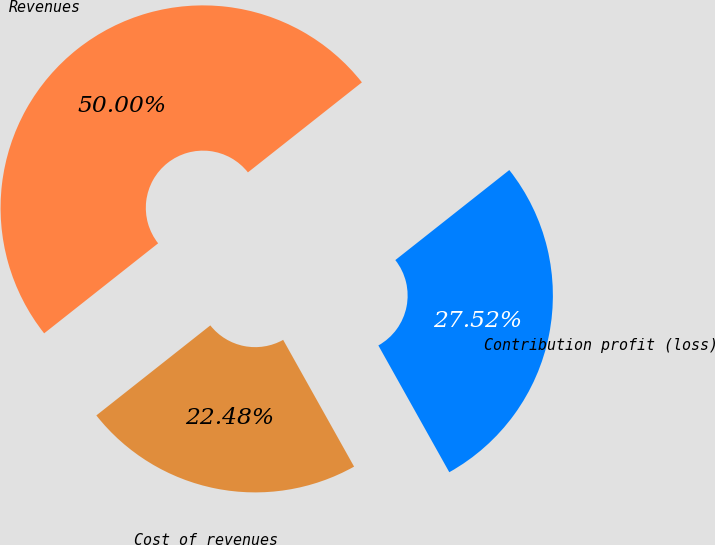<chart> <loc_0><loc_0><loc_500><loc_500><pie_chart><fcel>Revenues<fcel>Cost of revenues<fcel>Contribution profit (loss)<nl><fcel>50.0%<fcel>22.48%<fcel>27.52%<nl></chart> 